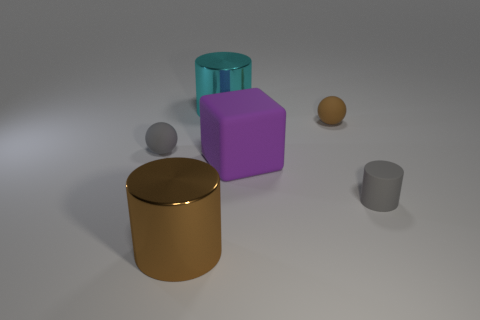There is a ball left of the metal cylinder behind the small matte ball that is to the right of the gray rubber sphere; what color is it?
Your answer should be compact. Gray. Do the cyan metal object and the large brown thing have the same shape?
Make the answer very short. Yes. Is the number of tiny rubber balls that are behind the cyan cylinder the same as the number of purple matte blocks?
Your answer should be very brief. No. What number of other objects are the same material as the brown cylinder?
Your answer should be compact. 1. Does the cylinder that is right of the big matte cube have the same size as the shiny cylinder that is to the right of the brown metallic cylinder?
Give a very brief answer. No. How many things are rubber objects that are behind the tiny rubber cylinder or small spheres behind the gray sphere?
Offer a very short reply. 3. Is there any other thing that has the same shape as the purple matte thing?
Make the answer very short. No. Does the shiny object behind the tiny gray rubber cylinder have the same color as the large metal thing on the left side of the big cyan shiny object?
Give a very brief answer. No. How many shiny things are large cyan objects or blue cylinders?
Give a very brief answer. 1. What is the shape of the gray rubber thing left of the brown thing that is behind the big brown metal cylinder?
Keep it short and to the point. Sphere. 